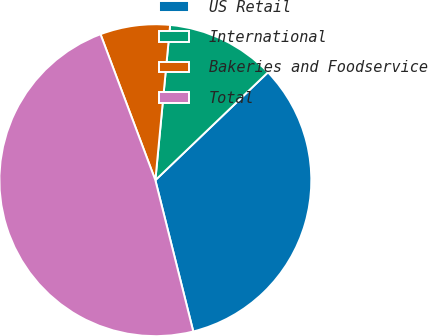Convert chart. <chart><loc_0><loc_0><loc_500><loc_500><pie_chart><fcel>US Retail<fcel>International<fcel>Bakeries and Foodservice<fcel>Total<nl><fcel>33.25%<fcel>11.33%<fcel>7.23%<fcel>48.19%<nl></chart> 